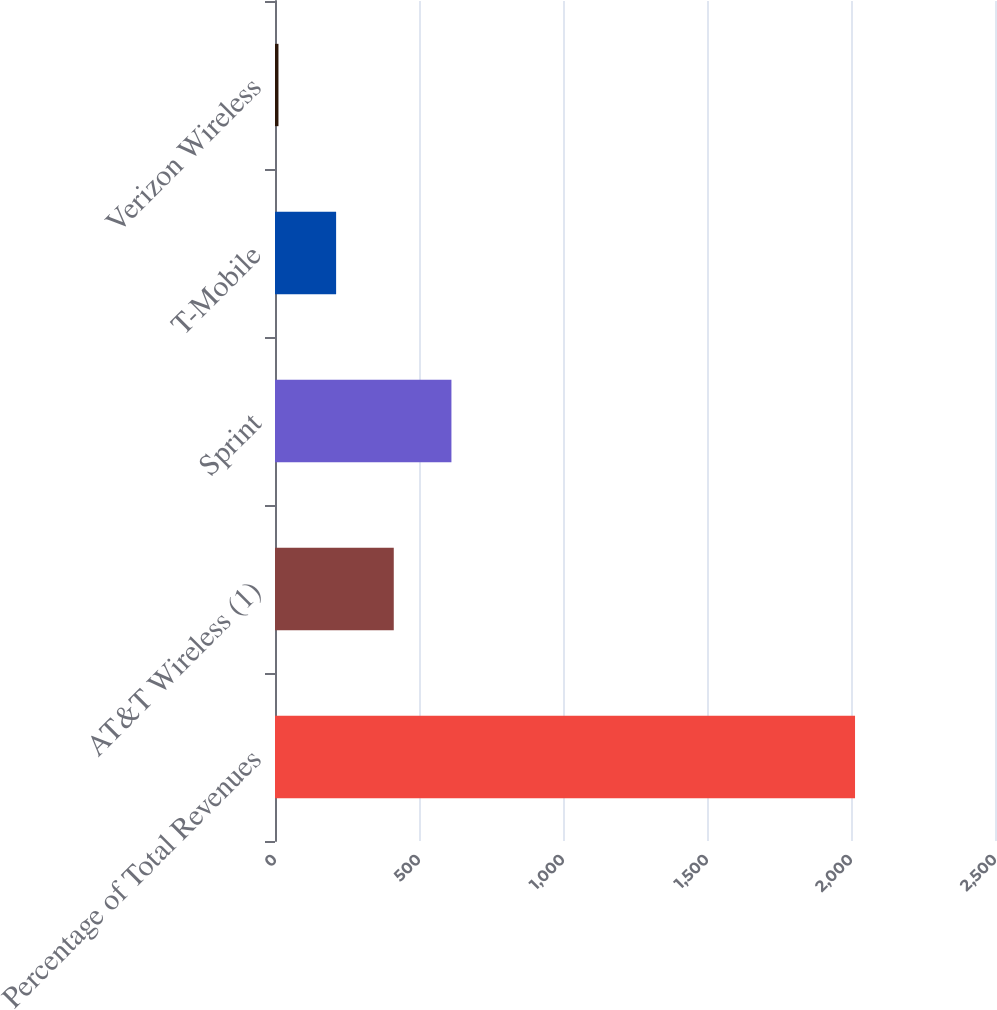Convert chart to OTSL. <chart><loc_0><loc_0><loc_500><loc_500><bar_chart><fcel>Percentage of Total Revenues<fcel>AT&T Wireless (1)<fcel>Sprint<fcel>T-Mobile<fcel>Verizon Wireless<nl><fcel>2014<fcel>412.4<fcel>612.6<fcel>212.2<fcel>12<nl></chart> 